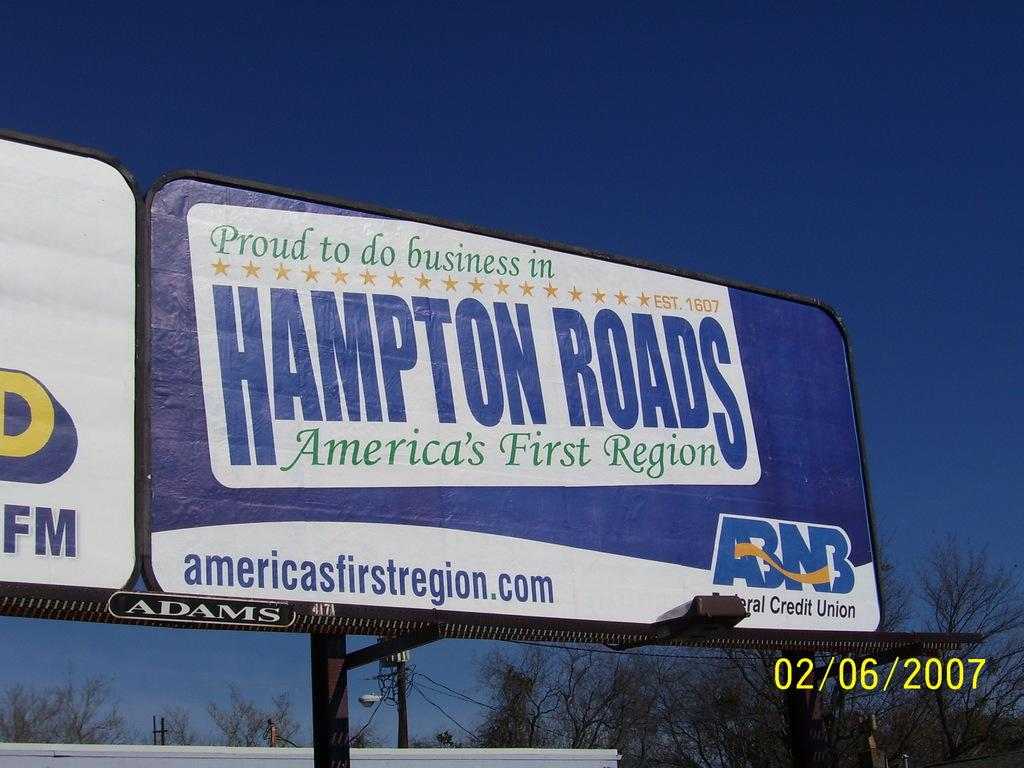Provide a one-sentence caption for the provided image. A billboard featuring Hampton Roads, America's First Region. 